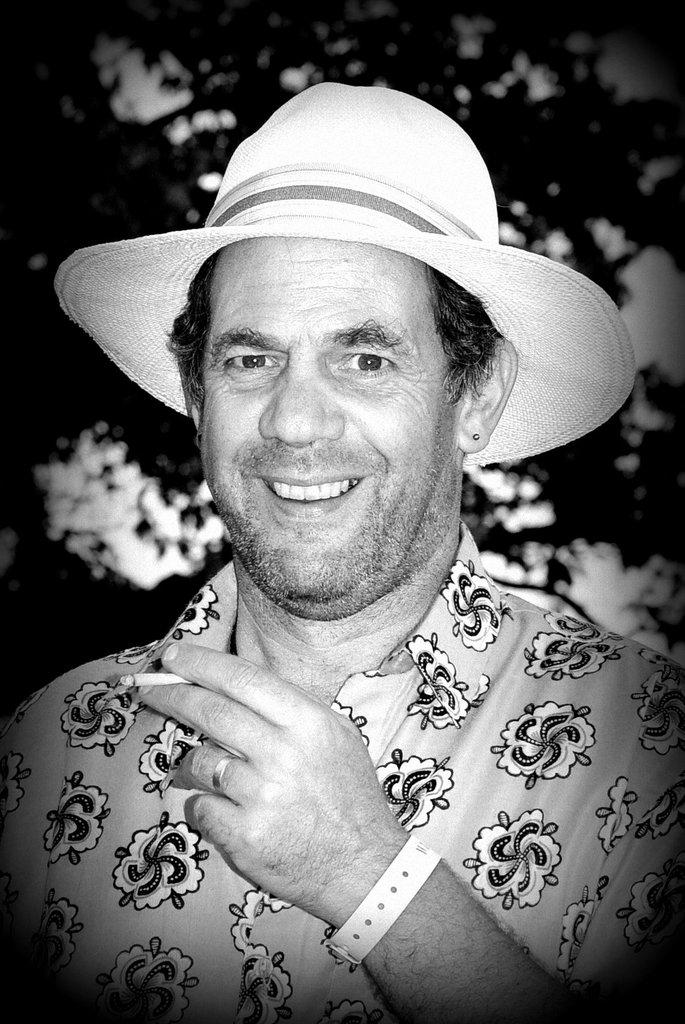What is the main subject of the image? There is a person in the image. What is the person wearing? The person is wearing a dress and a hat. What is the person's facial expression? The person is smiling. What can be seen in the background of the image? There are many trees in the background of the image. What is the color scheme of the image? The image is in black and white color. Can you see a kitty playing with the person's hat in the image? There is no kitty present in the image, and therefore no such activity can be observed. How many beds are visible in the image? There are no beds visible in the image; it features a person in a dress and hat, with trees in the background. 